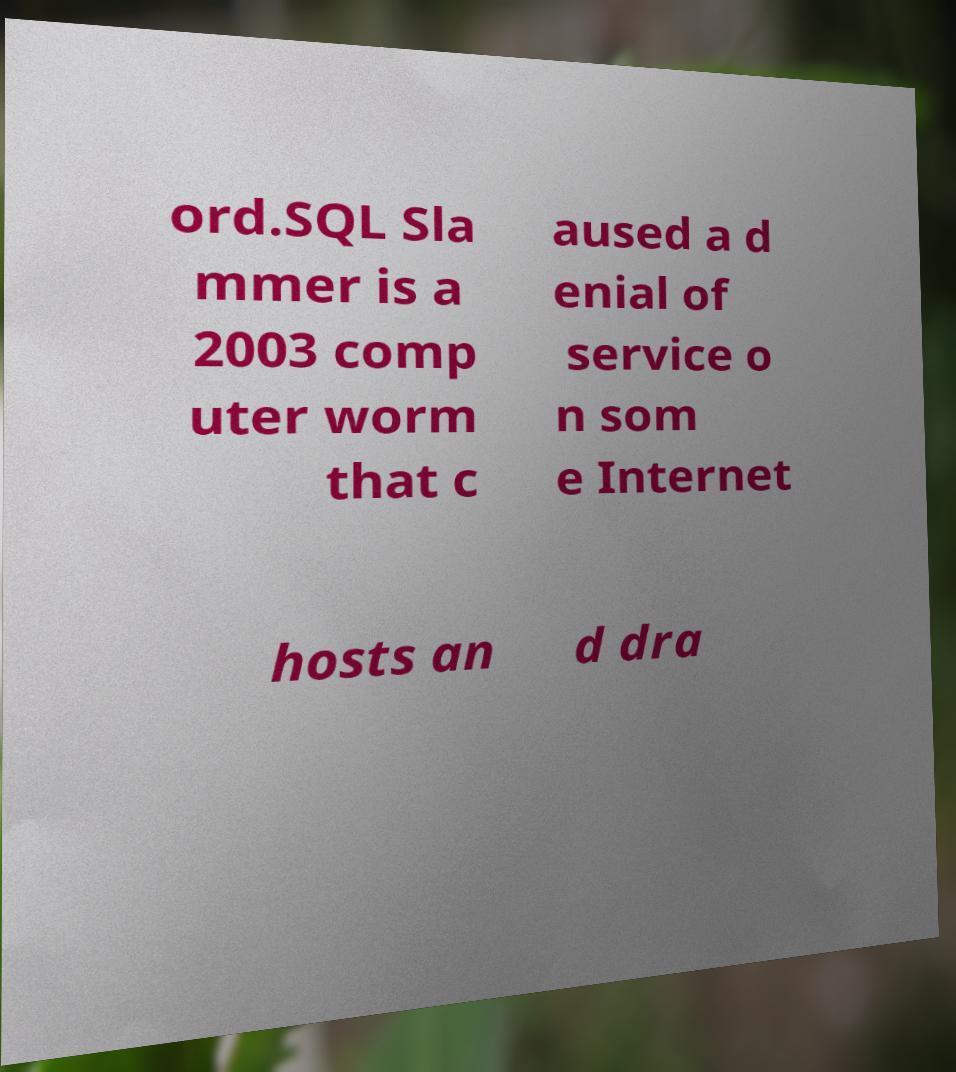I need the written content from this picture converted into text. Can you do that? ord.SQL Sla mmer is a 2003 comp uter worm that c aused a d enial of service o n som e Internet hosts an d dra 